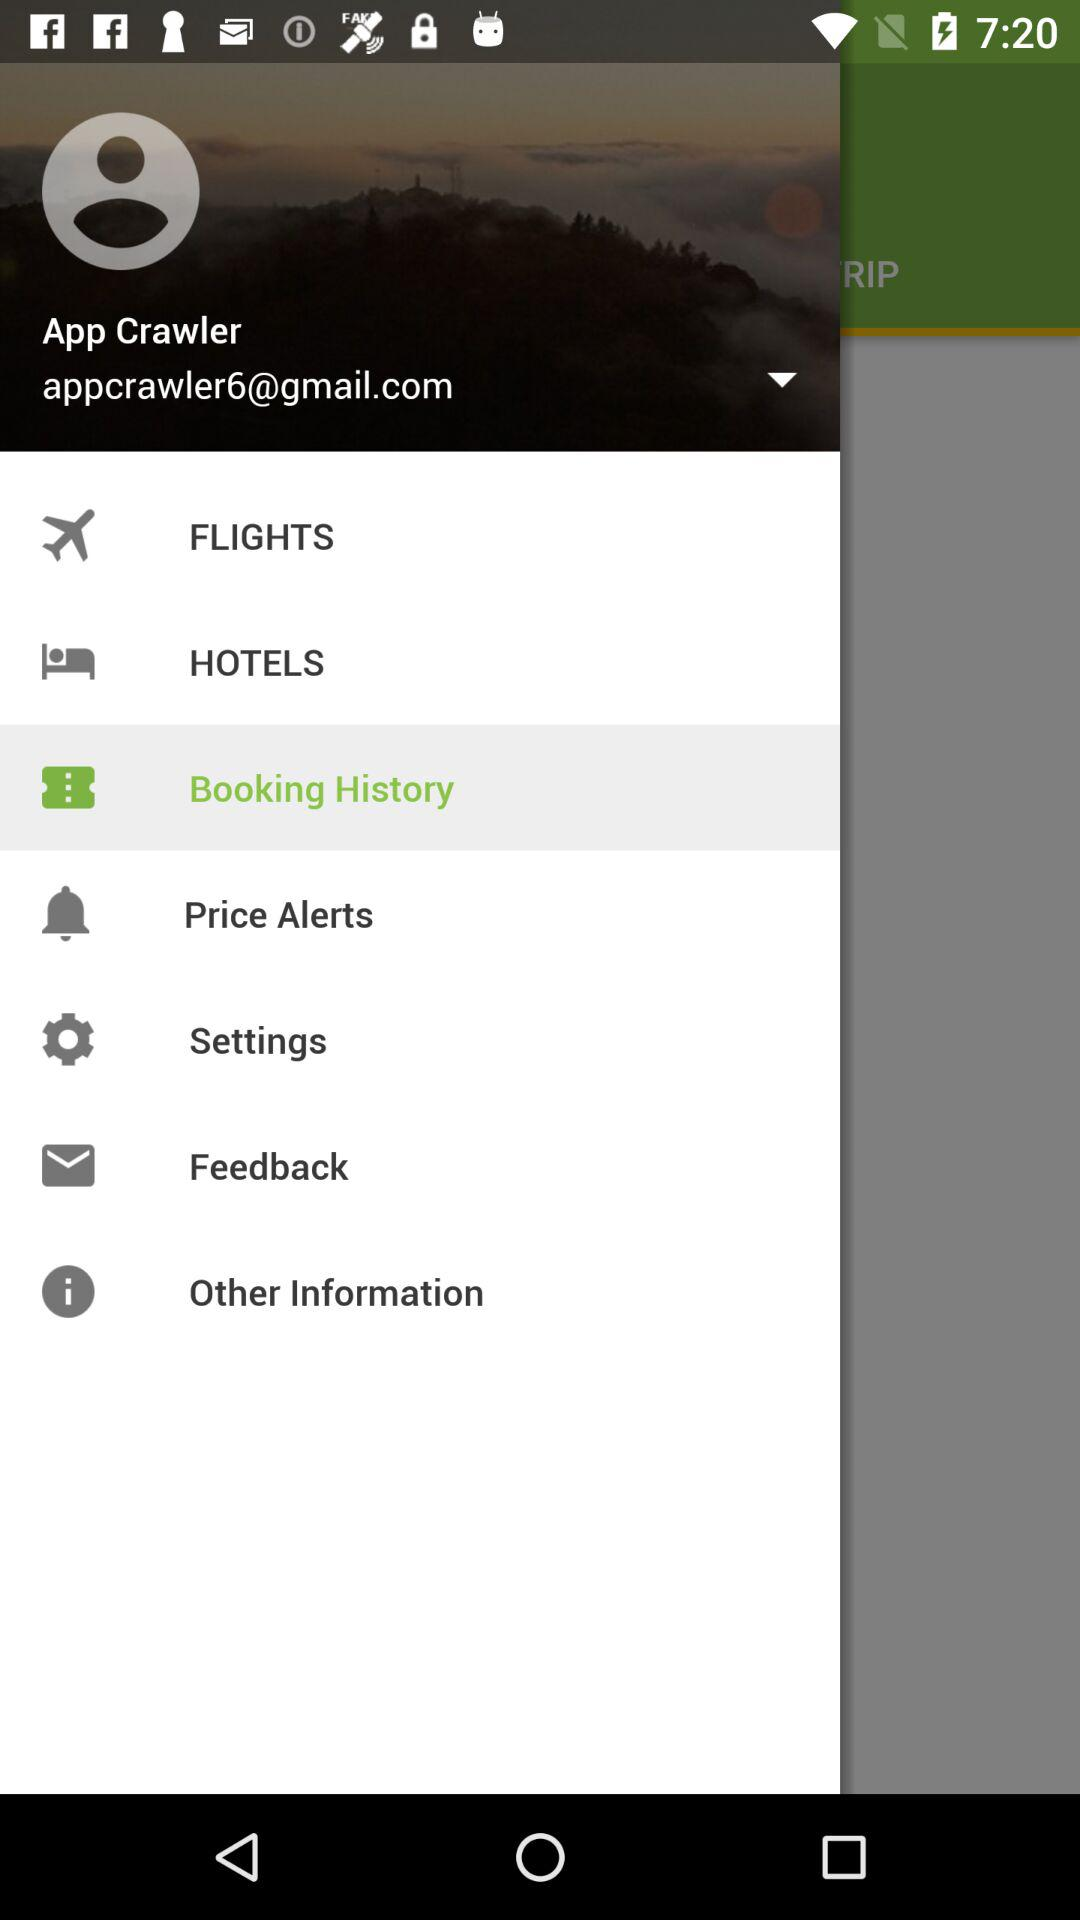Which item is selected? The selected item is "Booking History". 